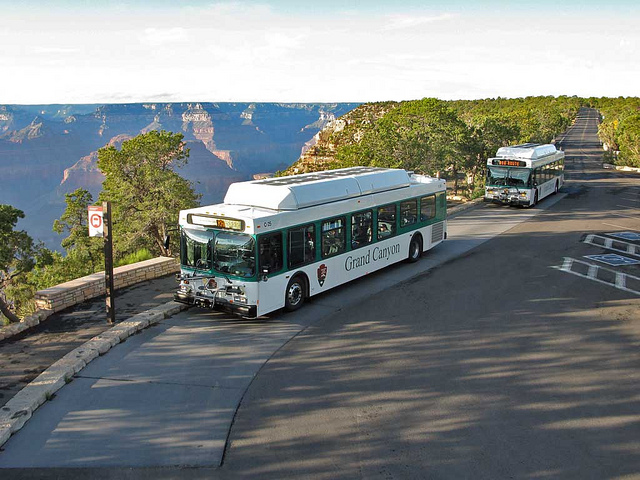Extract all visible text content from this image. Grand Canyon 